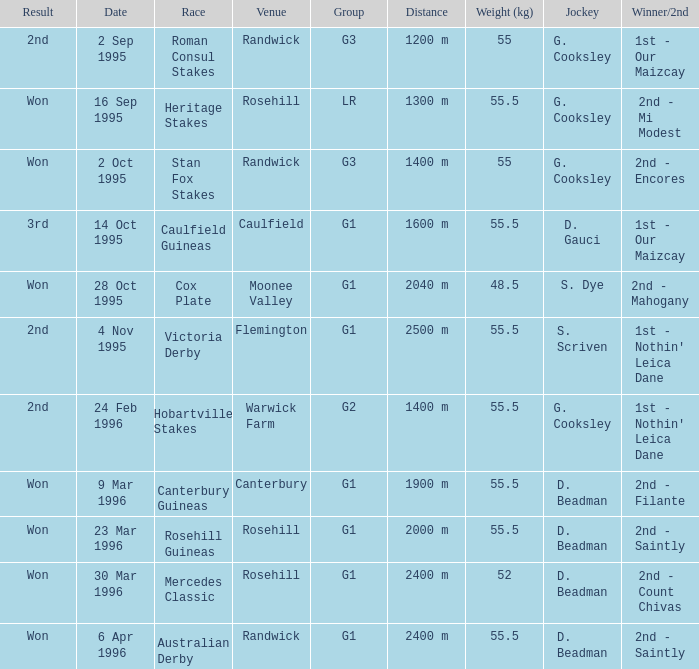What venue hosted the stan fox stakes? Randwick. 